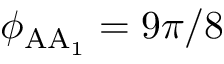<formula> <loc_0><loc_0><loc_500><loc_500>\phi _ { A A _ { 1 } } = 9 \pi / 8</formula> 